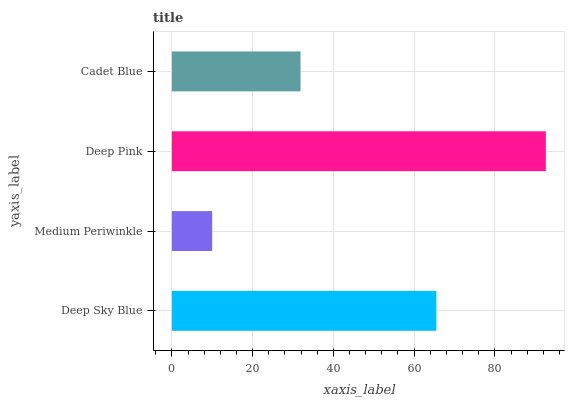Is Medium Periwinkle the minimum?
Answer yes or no. Yes. Is Deep Pink the maximum?
Answer yes or no. Yes. Is Deep Pink the minimum?
Answer yes or no. No. Is Medium Periwinkle the maximum?
Answer yes or no. No. Is Deep Pink greater than Medium Periwinkle?
Answer yes or no. Yes. Is Medium Periwinkle less than Deep Pink?
Answer yes or no. Yes. Is Medium Periwinkle greater than Deep Pink?
Answer yes or no. No. Is Deep Pink less than Medium Periwinkle?
Answer yes or no. No. Is Deep Sky Blue the high median?
Answer yes or no. Yes. Is Cadet Blue the low median?
Answer yes or no. Yes. Is Deep Pink the high median?
Answer yes or no. No. Is Deep Sky Blue the low median?
Answer yes or no. No. 